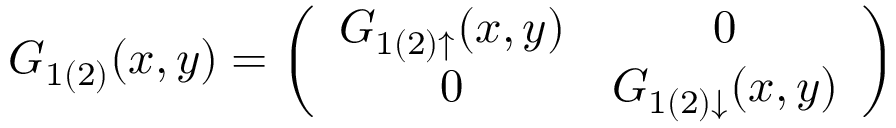<formula> <loc_0><loc_0><loc_500><loc_500>G _ { 1 ( 2 ) } ( x , y ) = \left ( \begin{array} { c c } { { G _ { 1 ( 2 ) \uparrow } ( x , y ) } } & { 0 } \\ { 0 } & { { G _ { 1 ( 2 ) \downarrow } ( x , y ) } } \end{array} \right )</formula> 